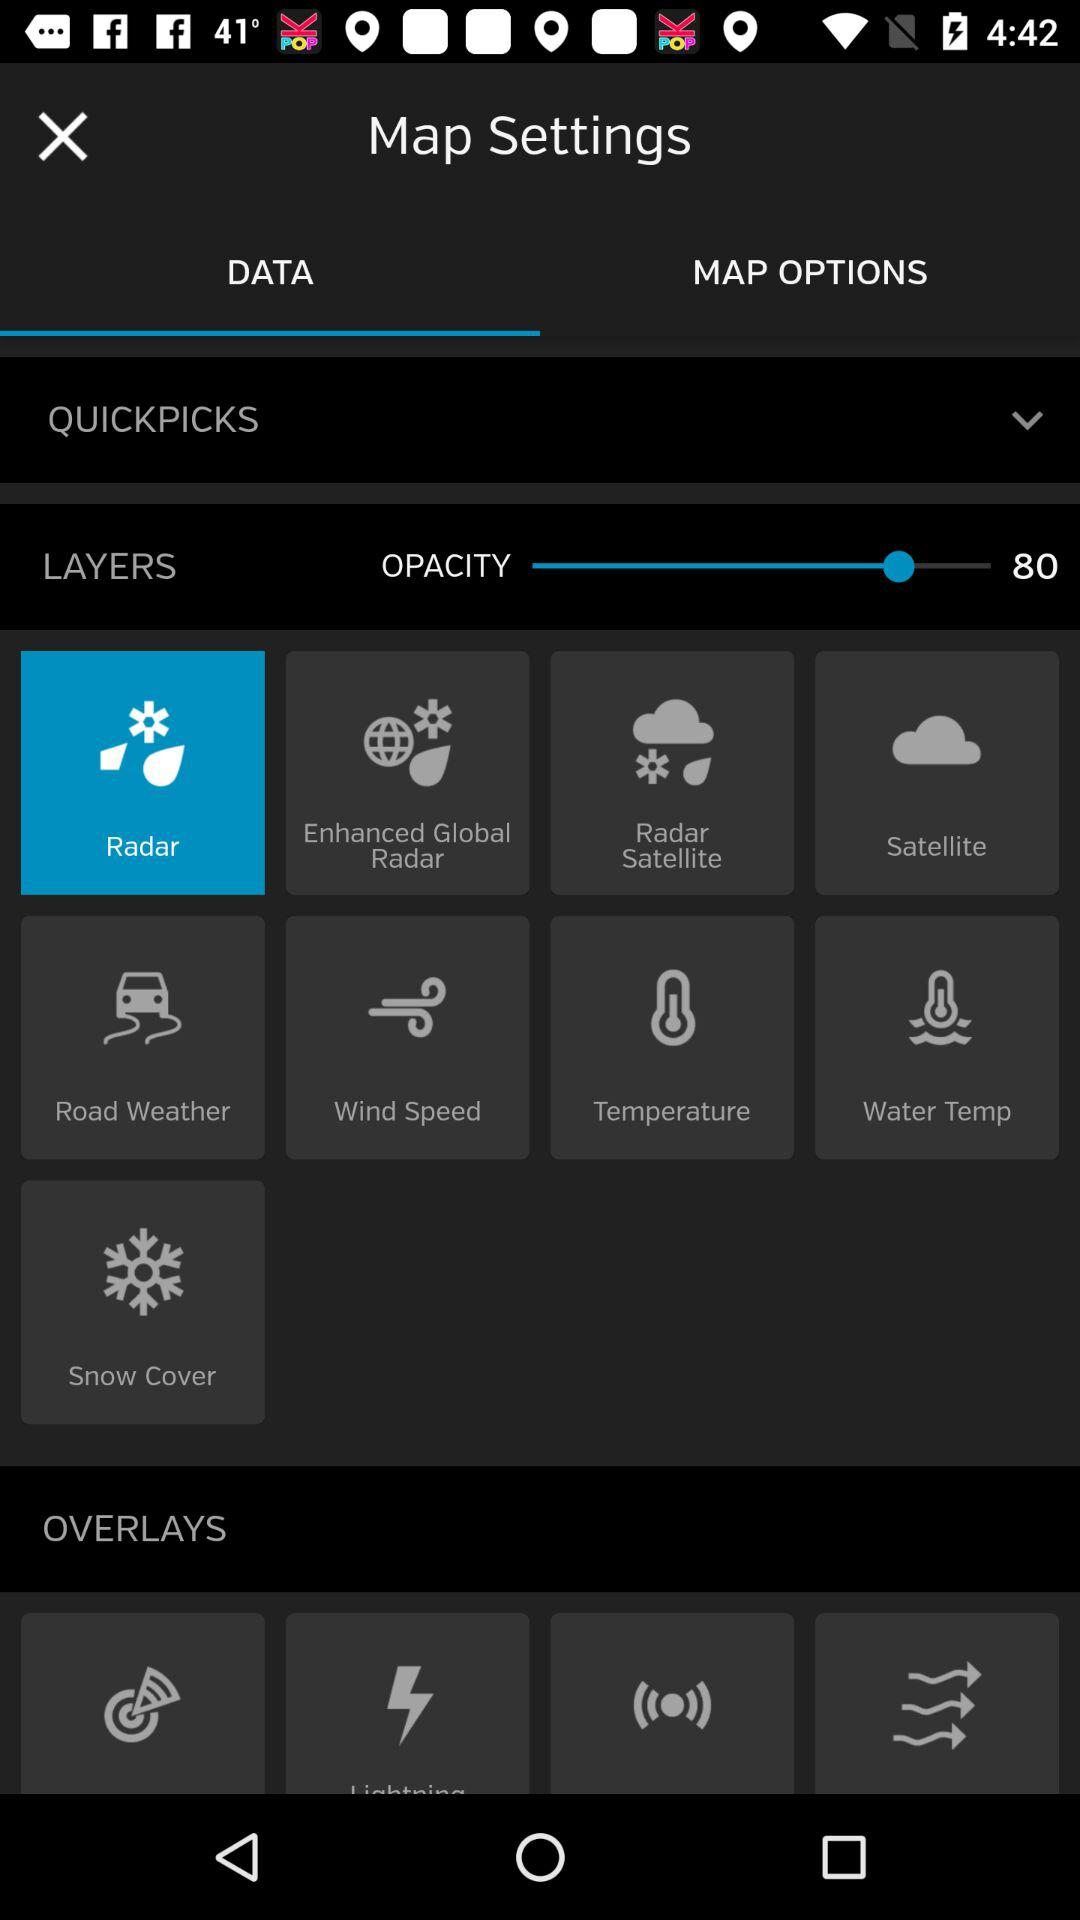What is the layer size?
When the provided information is insufficient, respond with <no answer>. <no answer> 